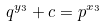<formula> <loc_0><loc_0><loc_500><loc_500>q ^ { y _ { 3 } } + c = p ^ { x _ { 3 } }</formula> 